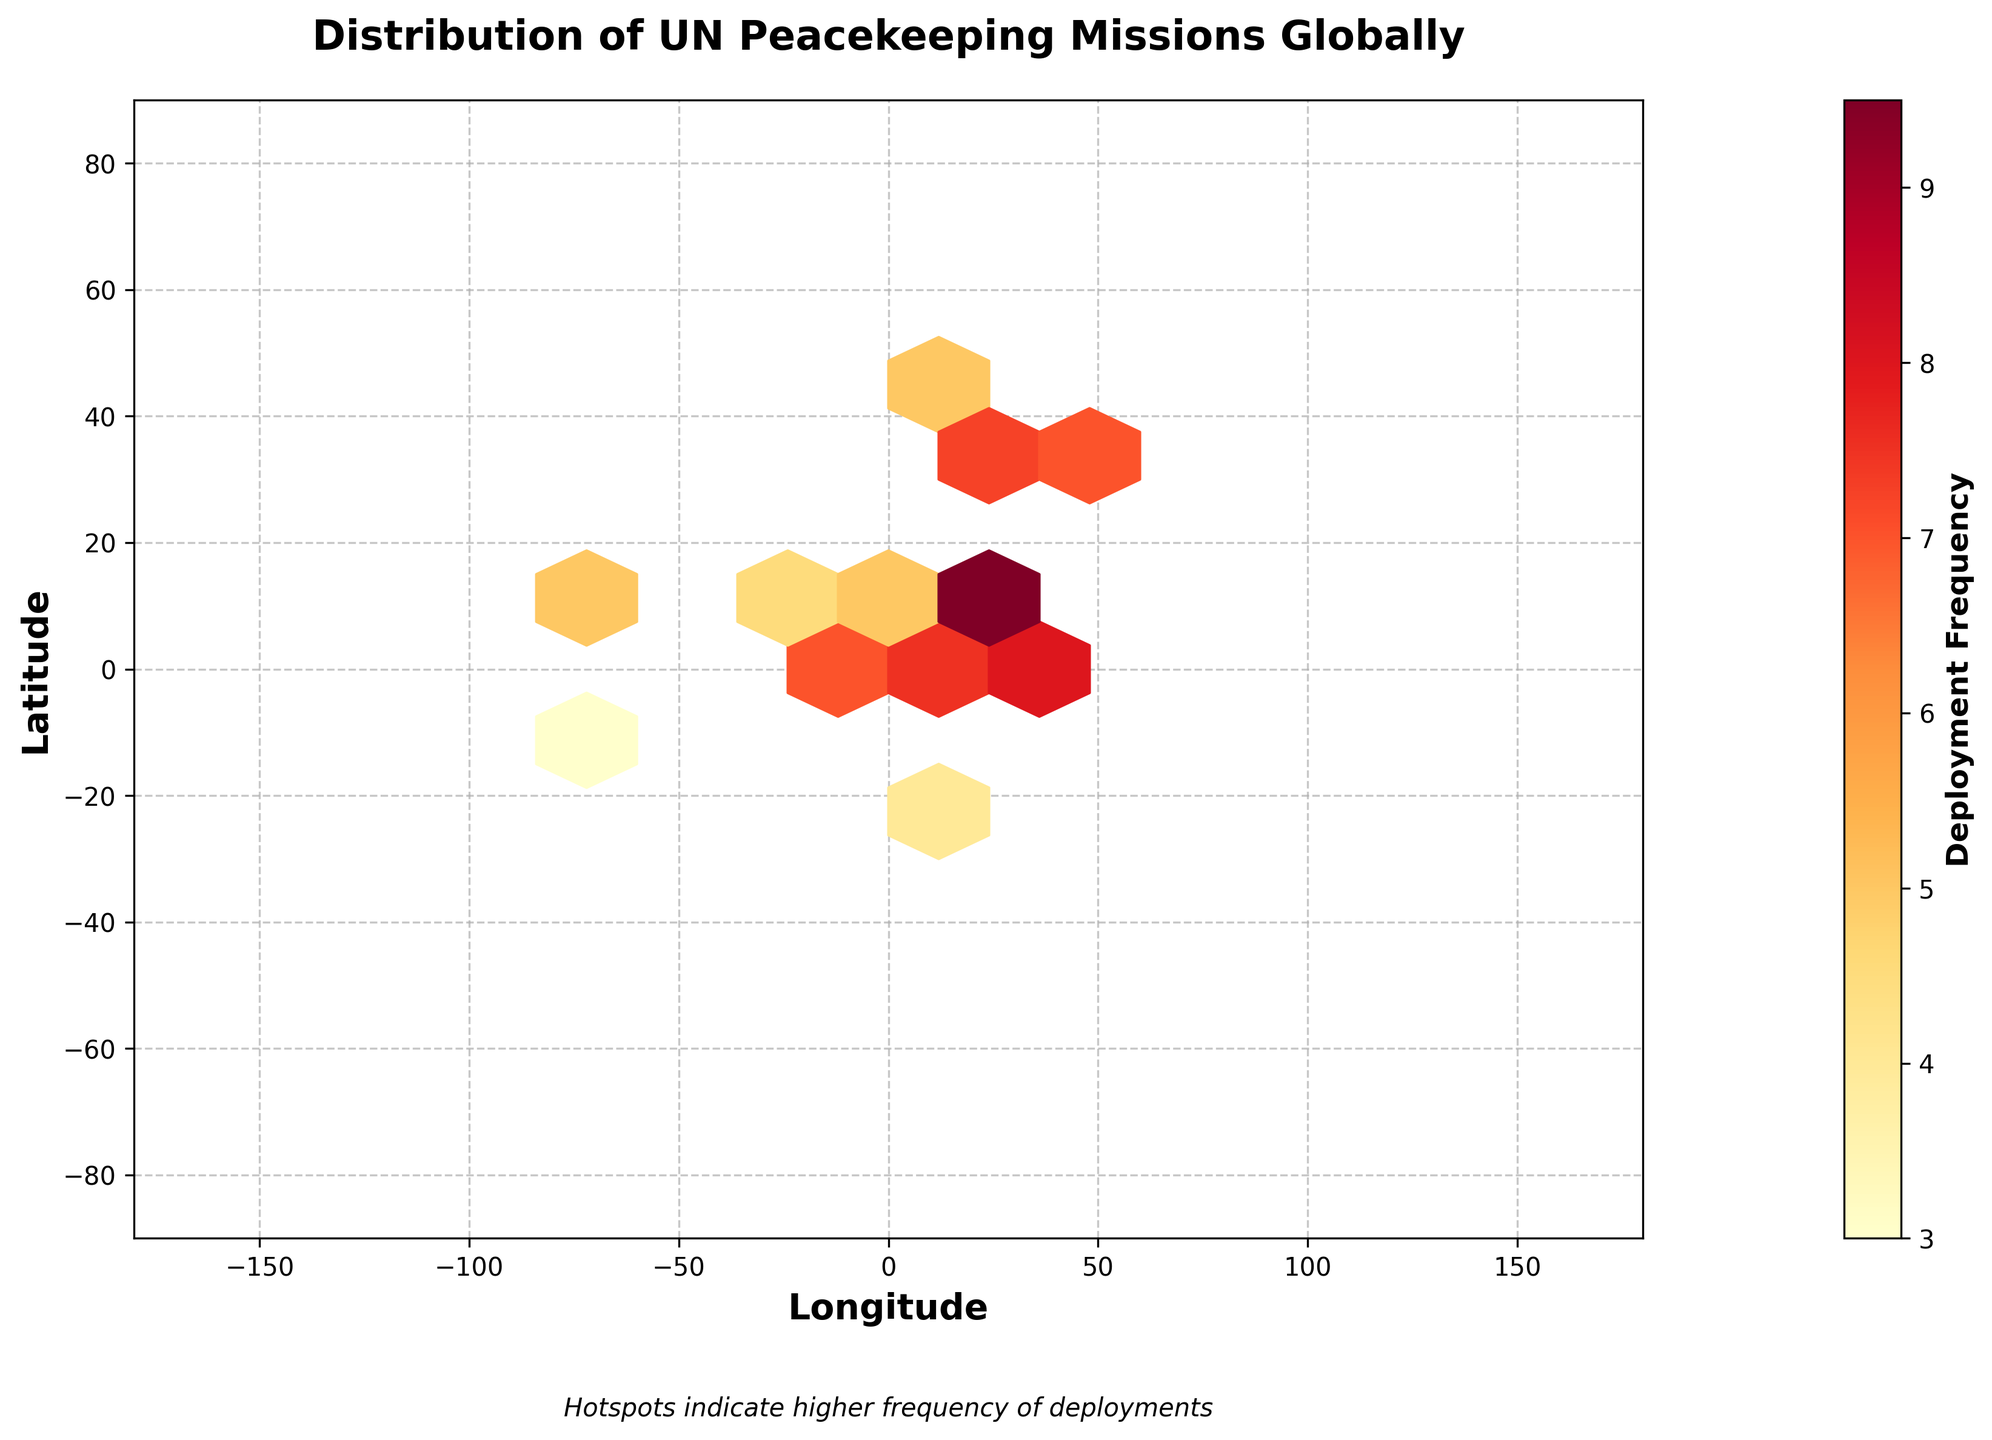What is the title of the plot? The title is usually located at the top of the plot and stands out because of its larger and bold font. Here, the title is "Distribution of UN Peacekeeping Missions Globally".
Answer: Distribution of UN Peacekeeping Missions Globally What does the color scale represent in the plot? The color scale or color bar is labeled on the right side of the plot with the term "Deployment Frequency". This indicates the frequency of deployments.
Answer: Deployment Frequency How is deployment frequency indicated in the hexbin plot? Colors range from lighter shades to darker shades, with lighter indicating lower frequencies and darker indicating higher frequencies, as shown in the color legend on the right side of the plot.
Answer: By color intensity Which area has the highest frequency of UN peacekeeping mission deployments? The darkest spot on the plot indicates the highest frequency. Looking at the plot, we refer to the corresponding point on the map around the region of Africa.
Answer: Africa Which continents appear to have more frequent UN peacekeeping missions? By observing the areas with higher concentrations of darker hexagons, it is evident that Africa and the Middle East have more frequent UN peacekeeping missions.
Answer: Africa and the Middle East What is the longitude and latitude range displayed in the plot? The x-axis (Longitude) ranges from -180 to 180 degrees, while the y-axis (Latitude) ranges from -90 to 90 degrees as indicated on their respective axis labels.
Answer: -180 to 180 (longitude), -90 to 90 (latitude) How does the frequency of deployments in South America compare to those in Africa? South America has fewer and lighter hexagons compared to Africa, indicating fewer and less frequent UN peacekeeping missions.
Answer: Less frequent in South America Where are sea and ocean areas typically marked on the plot? Areas over the sea and oceans are shown as empty spaces without colored hexagons, often indicating no or very low frequency of deployments.
Answer: Marked usually with no hexagons What regions have a frequency of around 8? There are multiple dark orange to red hexagons in regions like the Middle East and parts of Africa, indicating a frequency around 8, as matched with the color bar.
Answer: Middle East and parts of Africa 